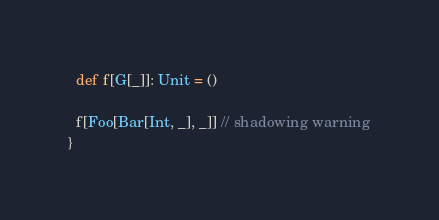Convert code to text. <code><loc_0><loc_0><loc_500><loc_500><_Scala_>  def f[G[_]]: Unit = ()

  f[Foo[Bar[Int, _], _]] // shadowing warning
}
</code> 